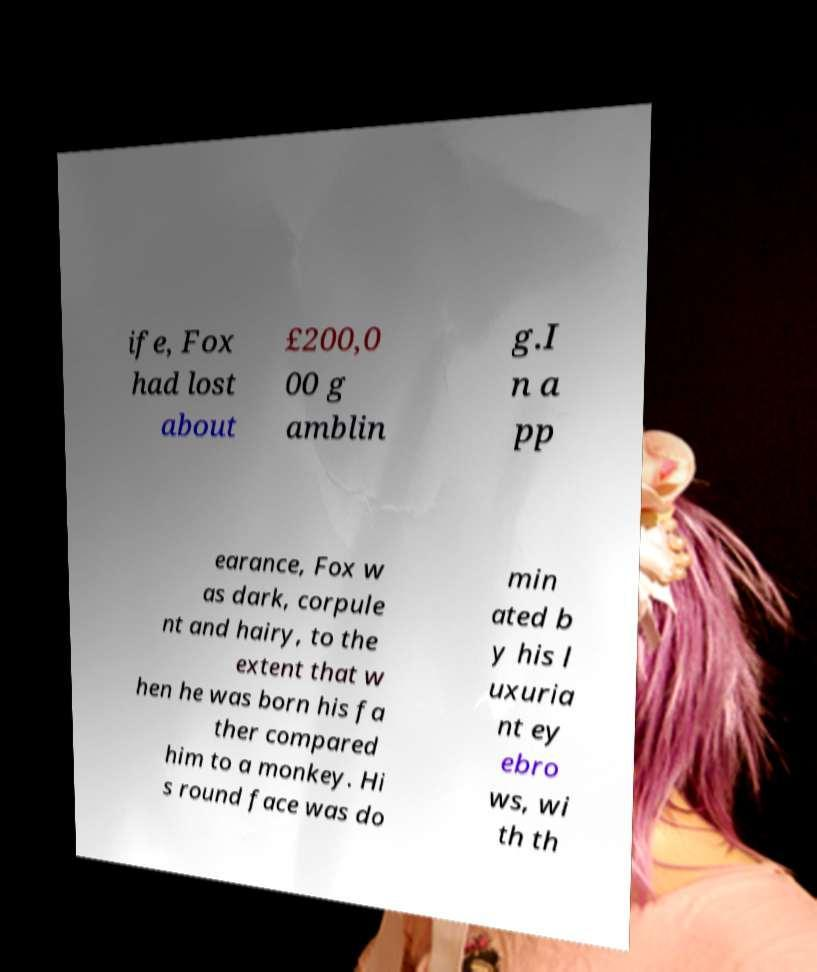Could you extract and type out the text from this image? ife, Fox had lost about £200,0 00 g amblin g.I n a pp earance, Fox w as dark, corpule nt and hairy, to the extent that w hen he was born his fa ther compared him to a monkey. Hi s round face was do min ated b y his l uxuria nt ey ebro ws, wi th th 